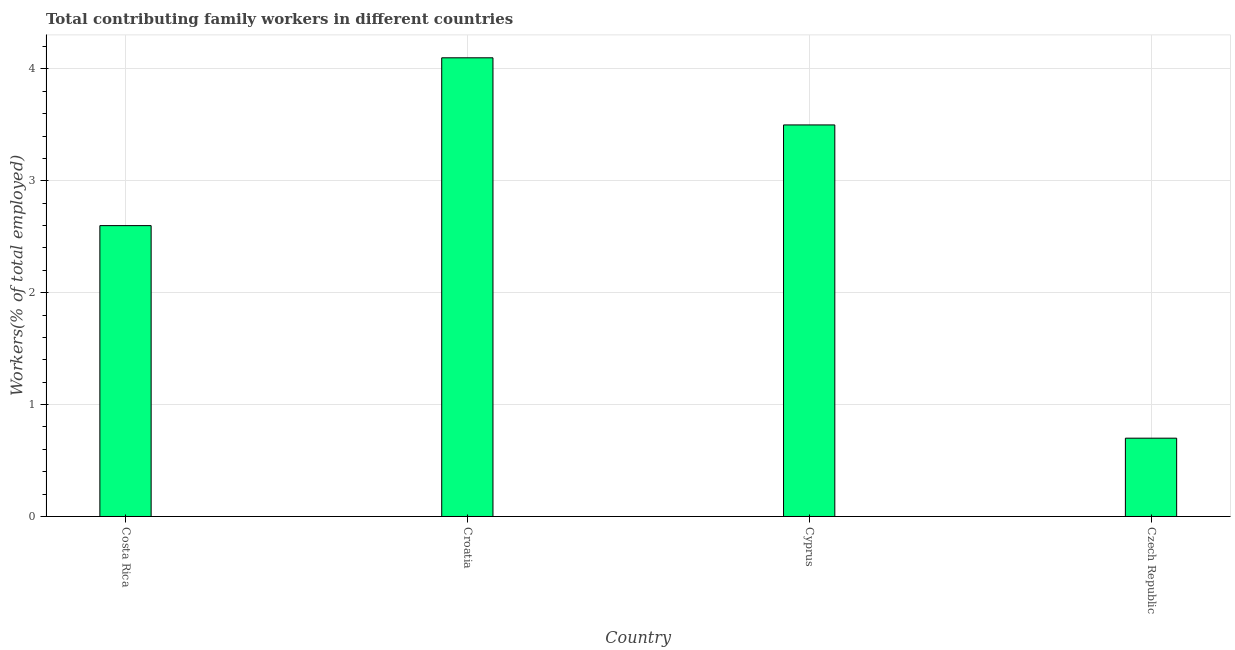What is the title of the graph?
Your answer should be very brief. Total contributing family workers in different countries. What is the label or title of the X-axis?
Provide a short and direct response. Country. What is the label or title of the Y-axis?
Provide a short and direct response. Workers(% of total employed). What is the contributing family workers in Cyprus?
Ensure brevity in your answer.  3.5. Across all countries, what is the maximum contributing family workers?
Your answer should be very brief. 4.1. Across all countries, what is the minimum contributing family workers?
Give a very brief answer. 0.7. In which country was the contributing family workers maximum?
Offer a very short reply. Croatia. In which country was the contributing family workers minimum?
Give a very brief answer. Czech Republic. What is the sum of the contributing family workers?
Offer a very short reply. 10.9. What is the average contributing family workers per country?
Your answer should be compact. 2.73. What is the median contributing family workers?
Make the answer very short. 3.05. In how many countries, is the contributing family workers greater than 1.8 %?
Your response must be concise. 3. What is the ratio of the contributing family workers in Croatia to that in Cyprus?
Provide a short and direct response. 1.17. Is the difference between the contributing family workers in Cyprus and Czech Republic greater than the difference between any two countries?
Ensure brevity in your answer.  No. What is the difference between the highest and the second highest contributing family workers?
Your response must be concise. 0.6. In how many countries, is the contributing family workers greater than the average contributing family workers taken over all countries?
Provide a short and direct response. 2. How many bars are there?
Keep it short and to the point. 4. Are all the bars in the graph horizontal?
Your answer should be very brief. No. What is the Workers(% of total employed) in Costa Rica?
Make the answer very short. 2.6. What is the Workers(% of total employed) of Croatia?
Ensure brevity in your answer.  4.1. What is the Workers(% of total employed) of Czech Republic?
Provide a short and direct response. 0.7. What is the difference between the Workers(% of total employed) in Costa Rica and Czech Republic?
Offer a terse response. 1.9. What is the difference between the Workers(% of total employed) in Croatia and Cyprus?
Make the answer very short. 0.6. What is the difference between the Workers(% of total employed) in Cyprus and Czech Republic?
Your response must be concise. 2.8. What is the ratio of the Workers(% of total employed) in Costa Rica to that in Croatia?
Your response must be concise. 0.63. What is the ratio of the Workers(% of total employed) in Costa Rica to that in Cyprus?
Provide a short and direct response. 0.74. What is the ratio of the Workers(% of total employed) in Costa Rica to that in Czech Republic?
Your response must be concise. 3.71. What is the ratio of the Workers(% of total employed) in Croatia to that in Cyprus?
Your response must be concise. 1.17. What is the ratio of the Workers(% of total employed) in Croatia to that in Czech Republic?
Offer a terse response. 5.86. What is the ratio of the Workers(% of total employed) in Cyprus to that in Czech Republic?
Your answer should be very brief. 5. 